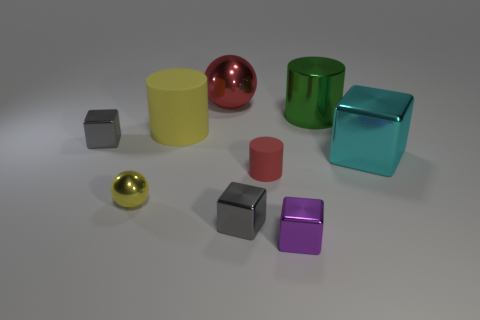Can you tell me about the lighting in the image and how it affects the appearance of the objects? The lighting in the image appears to be coming from the upper left area, casting subtle shadows to the right of the objects. This lighting creates highlights and reflections on the metallic objects, enhancing their shiny textures and emphasizing their geometric shapes. The soft and diffuse nature of the light allows the colors of the objects to be seen clearly without harsh shadows. 